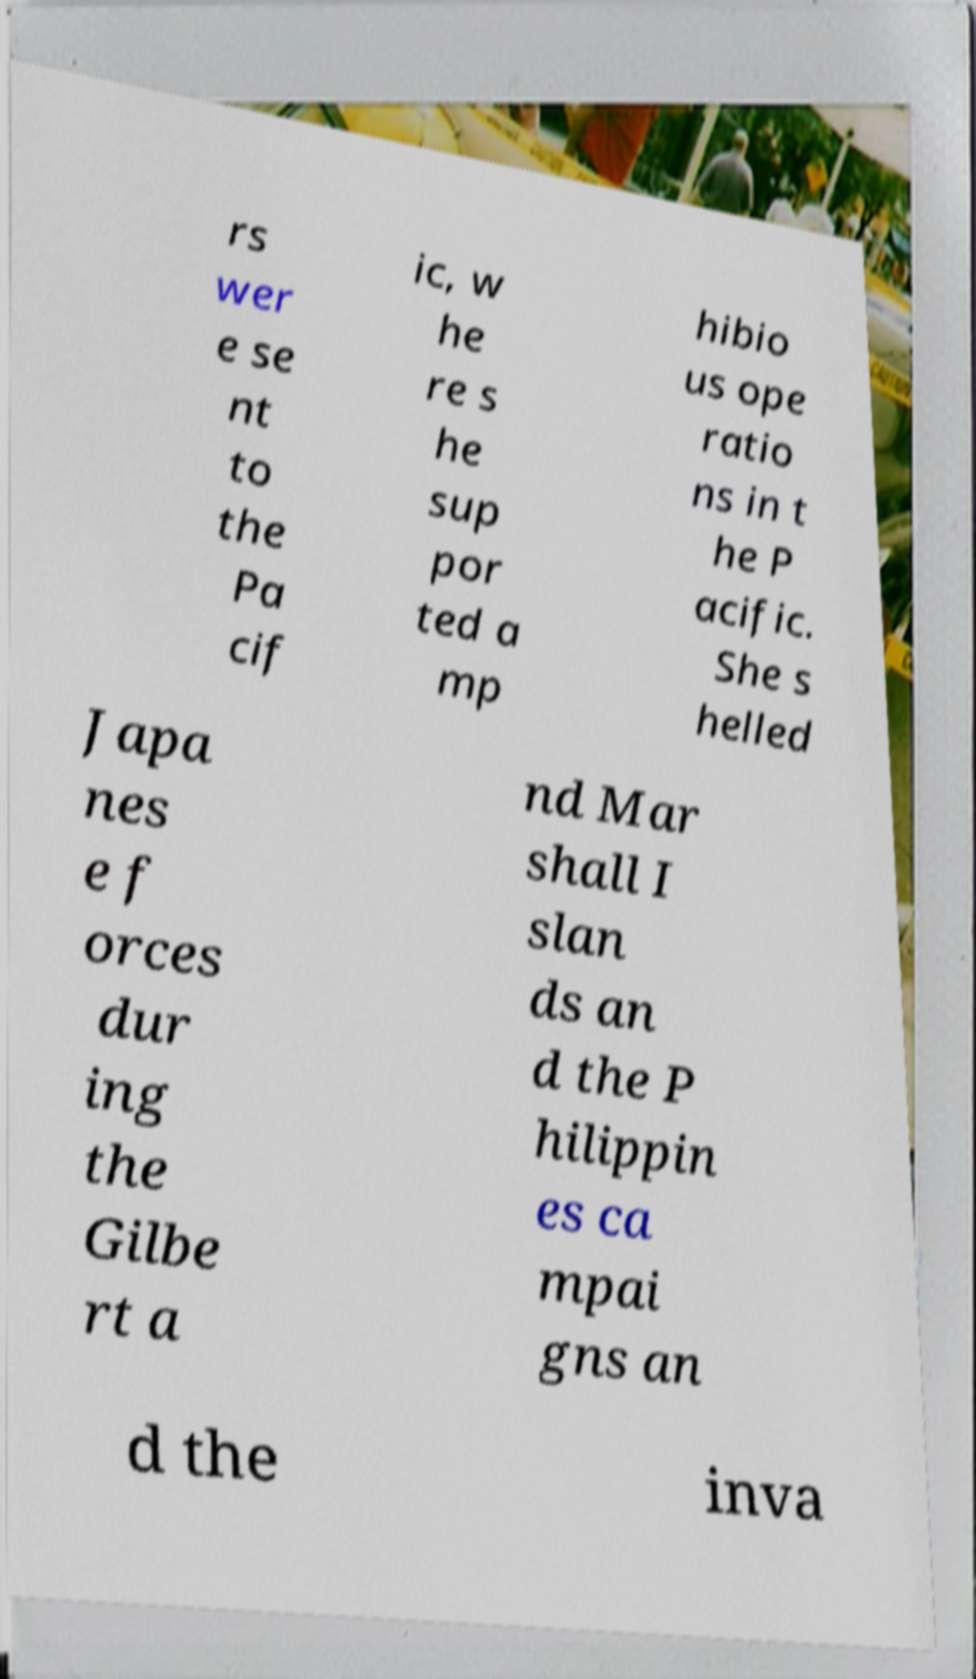Please read and relay the text visible in this image. What does it say? rs wer e se nt to the Pa cif ic, w he re s he sup por ted a mp hibio us ope ratio ns in t he P acific. She s helled Japa nes e f orces dur ing the Gilbe rt a nd Mar shall I slan ds an d the P hilippin es ca mpai gns an d the inva 